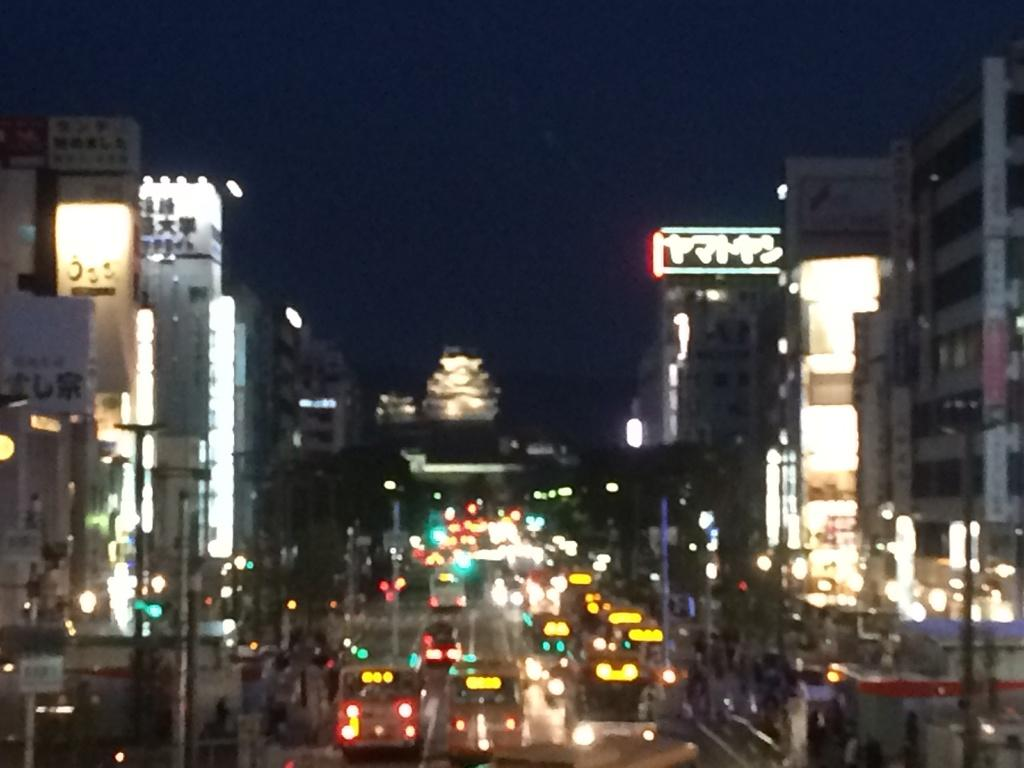What type of structures can be seen in the image? There are buildings in the image. What else can be seen on the ground in the image? There are vehicles on the road in the image. What can be seen illuminating the scene in the image? There are lights visible in the image. What is visible in the distance in the image? The sky is visible in the background of the image. What type of apparel is required to enter the buildings in the image? There is no information about apparel requirements for entering the buildings in the image. 